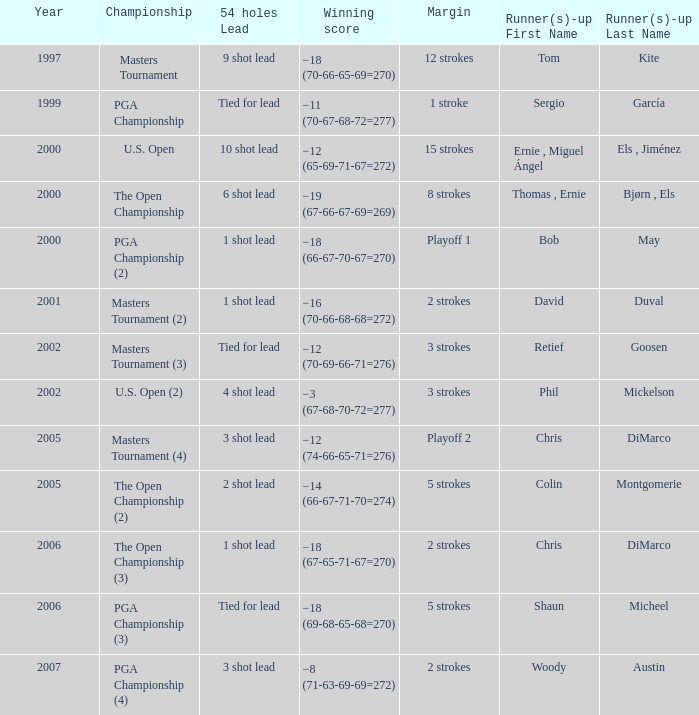What is the minimum year where winning score is −8 (71-63-69-69=272) 2007.0. 